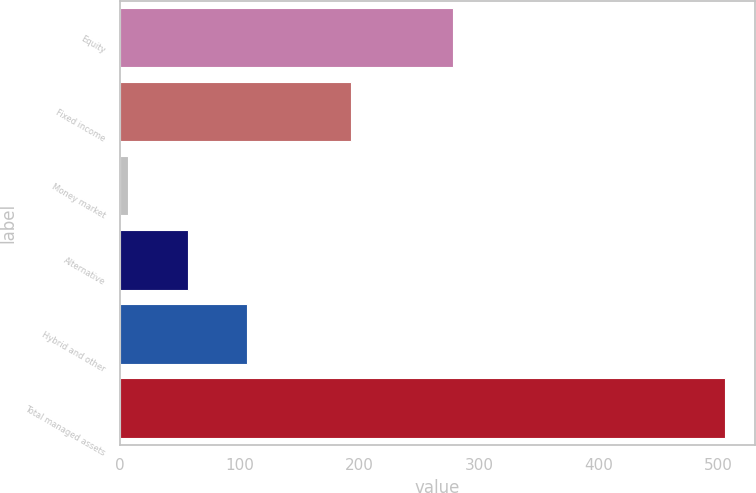Convert chart. <chart><loc_0><loc_0><loc_500><loc_500><bar_chart><fcel>Equity<fcel>Fixed income<fcel>Money market<fcel>Alternative<fcel>Hybrid and other<fcel>Total managed assets<nl><fcel>278.1<fcel>193.4<fcel>6.7<fcel>56.59<fcel>106.48<fcel>505.6<nl></chart> 